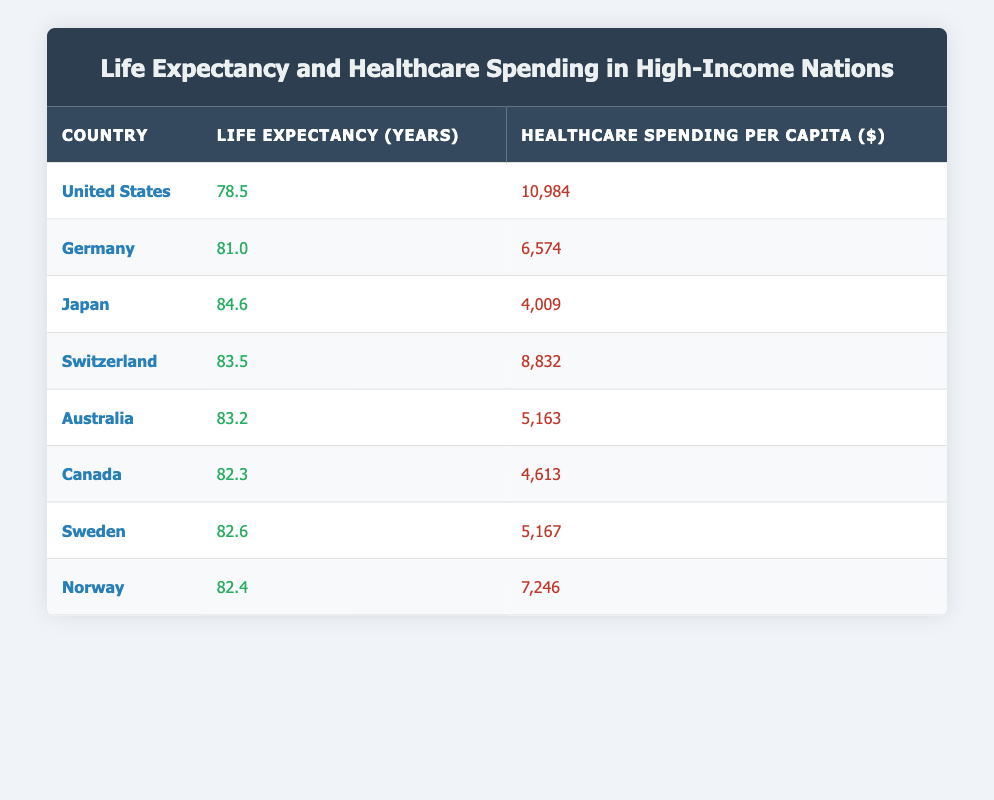What is the life expectancy of Japan? Japan's life expectancy is listed directly in the table as 84.6 years.
Answer: 84.6 Which country has the highest healthcare spending per capita? The table shows that the United States has the highest healthcare spending per capita at 10,984 dollars.
Answer: United States What is the life expectancy difference between the United States and Germany? The life expectancy for the United States is 78.5 years, and for Germany, it is 81.0 years. The difference is 81.0 - 78.5 = 2.5 years.
Answer: 2.5 years Is the healthcare spending for Australia greater than that for Canada? According to the table, Australia has healthcare spending of 5,163 dollars, while Canada has 4,613 dollars, which indicates that Australia’s spending is greater.
Answer: Yes What is the average life expectancy of the countries listed in the table? The life expectancies for the countries are: 78.5, 81.0, 84.6, 83.5, 83.2, 82.3, 82.6, and 82.4. Adding them gives a total of 678.1, which divided by 8 (total countries) results in an average of 84.9.
Answer: 81.0 How does the healthcare spending of Norway compare to that of Switzerland? Norway has healthcare spending of 7,246 dollars and Switzerland 8,832 dollars. Thus, Norway spends less on healthcare than Switzerland.
Answer: Norway spends less Which country has the second lowest healthcare spending per capita? The table indicates that Japan has the lowest spending at 4,009 dollars, followed by Canada with 4,613 dollars, making Canada the second lowest.
Answer: Canada If we sort life expectancies in descending order, which country would rank fifth? When sorting the life expectancies from highest to lowest: Japan, Switzerland, Australia, Sweden, and Canada, the fifth country is Canada with a life expectancy of 82.3 years.
Answer: Canada What is the total healthcare spending for the four countries with the highest life expectancies? The countries with the highest life expectancies (Japan, Switzerland, Australia, and Sweden) have spending of 4,009, 8,832, 5,163, and 5,167 dollars respectively. Adding these gives a total of 23,171 dollars.
Answer: 23,171 dollars 